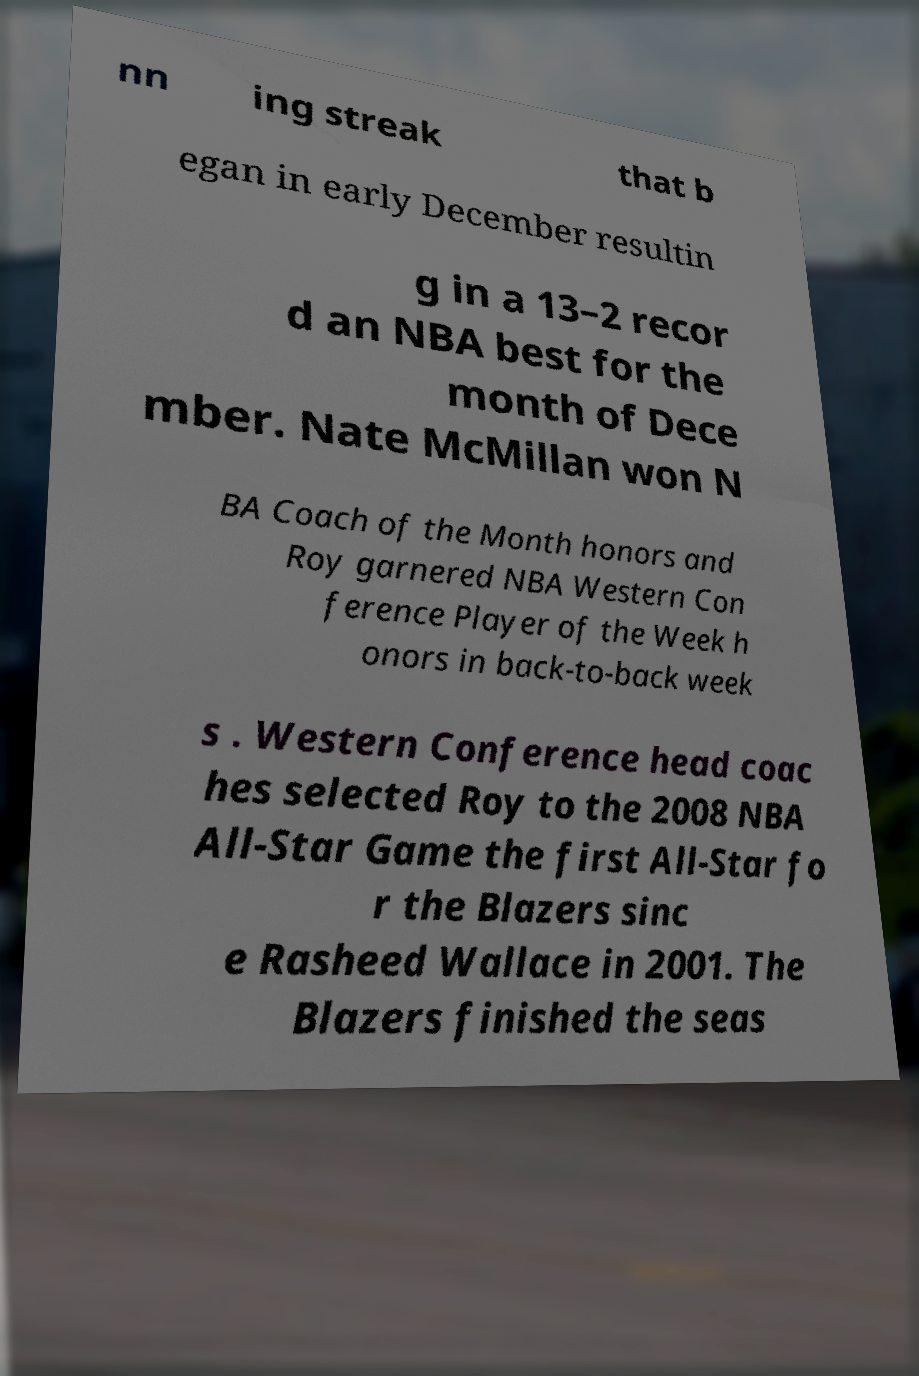Could you extract and type out the text from this image? nn ing streak that b egan in early December resultin g in a 13–2 recor d an NBA best for the month of Dece mber. Nate McMillan won N BA Coach of the Month honors and Roy garnered NBA Western Con ference Player of the Week h onors in back-to-back week s . Western Conference head coac hes selected Roy to the 2008 NBA All-Star Game the first All-Star fo r the Blazers sinc e Rasheed Wallace in 2001. The Blazers finished the seas 